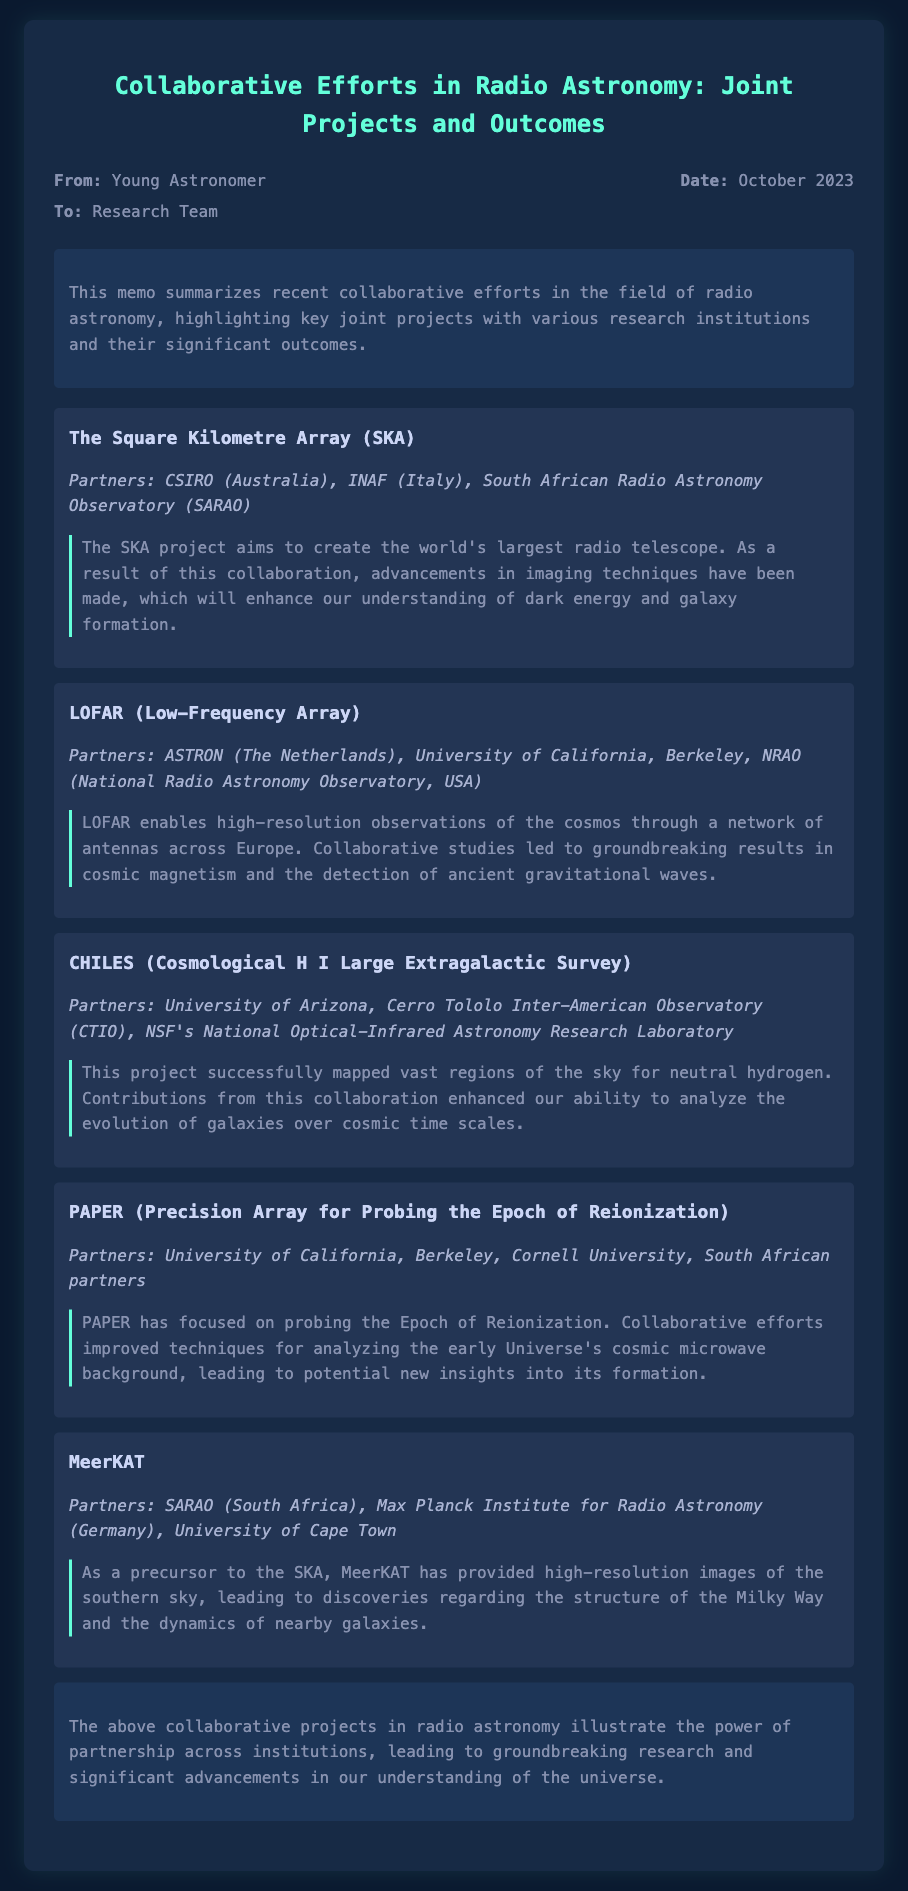What is the main focus of the memo? The memo summarizes recent collaborative efforts in radio astronomy, highlighting key joint projects with various research institutions and their significant outcomes.
Answer: Collaborative efforts in radio astronomy Who are the partners involved in the SKA project? The partners involved in the SKA project are mentioned in the document.
Answer: CSIRO (Australia), INAF (Italy), SARAO What significant advancement resulted from the LOFAR project? The document states that LOFAR led to groundbreaking results in cosmic magnetism and the detection of ancient gravitational waves.
Answer: Cosmic magnetism and gravitational waves How many projects are summarized in the memo? The document lists multiple projects, which can be counted.
Answer: Five Which project focused on mapping neutral hydrogen? The document specifies the project that achieved this goal.
Answer: CHILES What was a key outcome of the PAPER project? The document details the techniques that were improved through collaborative efforts in this project.
Answer: Analyzing the early Universe's cosmic microwave background What type of research does MeerKAT provide insights into? The document explains the discoveries made by MeerKAT, focusing on specific astronomical structures.
Answer: Structure of the Milky Way and dynamics of nearby galaxies What does the conclusion emphasize about collaborative projects? The conclusion summarizes the impact and significance of the collaborative projects discussed.
Answer: Power of partnership across institutions Who authored the memo? The document provides the name of the person who wrote it.
Answer: Young Astronomer 